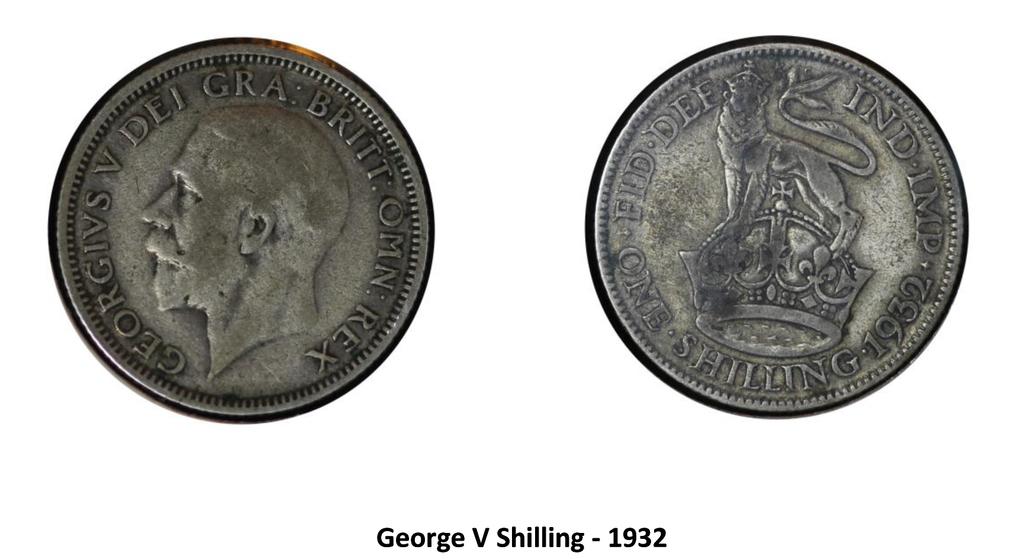What is the year at the bottom?
Offer a very short reply. 1932. 